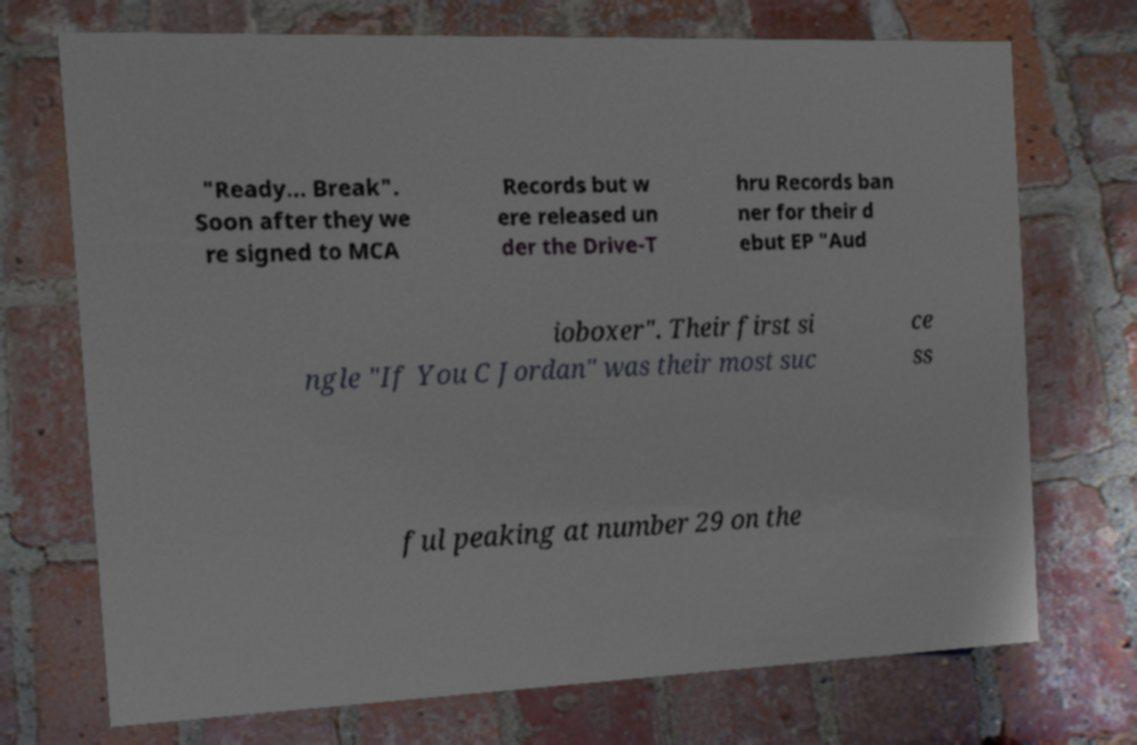For documentation purposes, I need the text within this image transcribed. Could you provide that? "Ready... Break". Soon after they we re signed to MCA Records but w ere released un der the Drive-T hru Records ban ner for their d ebut EP "Aud ioboxer". Their first si ngle "If You C Jordan" was their most suc ce ss ful peaking at number 29 on the 